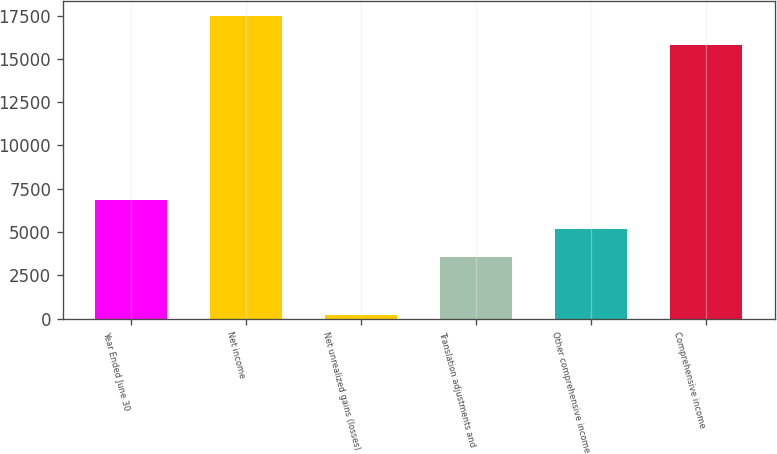Convert chart to OTSL. <chart><loc_0><loc_0><loc_500><loc_500><bar_chart><fcel>Year Ended June 30<fcel>Net income<fcel>Net unrealized gains (losses)<fcel>Translation adjustments and<fcel>Other comprehensive income<fcel>Comprehensive income<nl><fcel>6856<fcel>17470<fcel>228<fcel>3542<fcel>5199<fcel>15813<nl></chart> 